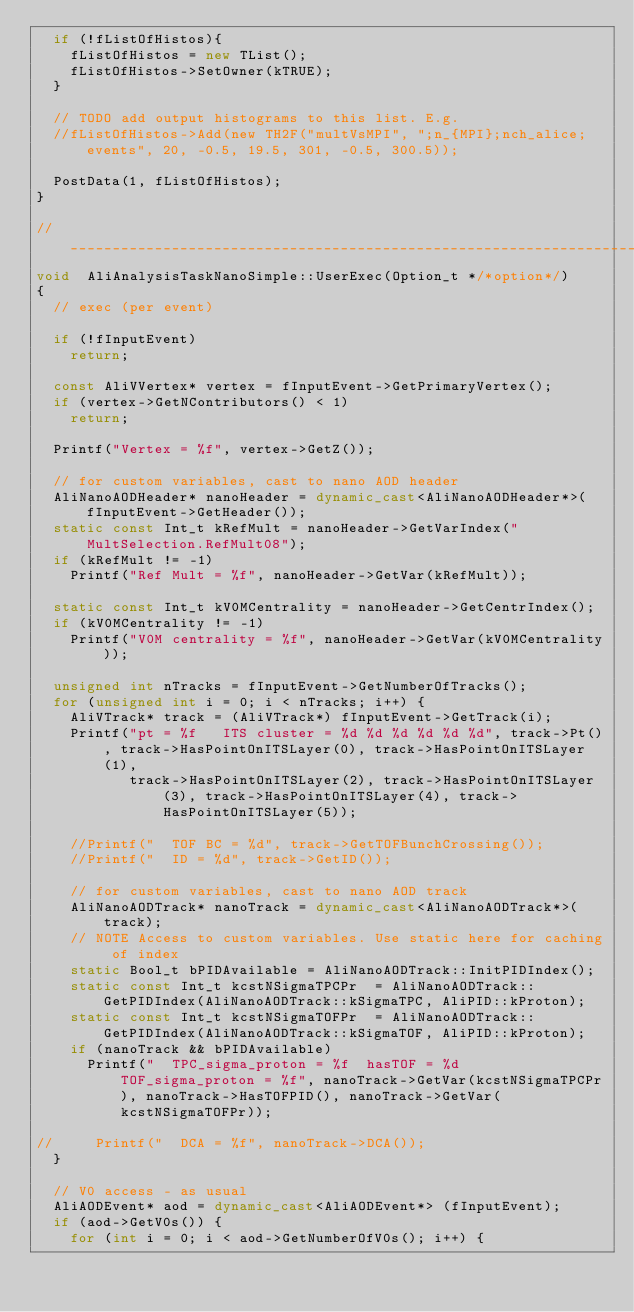<code> <loc_0><loc_0><loc_500><loc_500><_C++_>  if (!fListOfHistos){
    fListOfHistos = new TList();
    fListOfHistos->SetOwner(kTRUE); 
  }

  // TODO add output histograms to this list. E.g.
  //fListOfHistos->Add(new TH2F("multVsMPI", ";n_{MPI};nch_alice;events", 20, -0.5, 19.5, 301, -0.5, 300.5));
  
  PostData(1, fListOfHistos);
}

//____________________________________________________________________
void  AliAnalysisTaskNanoSimple::UserExec(Option_t */*option*/)
{
  // exec (per event)

  if (!fInputEvent)
    return;
  
  const AliVVertex* vertex = fInputEvent->GetPrimaryVertex();
  if (vertex->GetNContributors() < 1)
    return;
  
  Printf("Vertex = %f", vertex->GetZ());
  
  // for custom variables, cast to nano AOD header
  AliNanoAODHeader* nanoHeader = dynamic_cast<AliNanoAODHeader*>(fInputEvent->GetHeader());
  static const Int_t kRefMult = nanoHeader->GetVarIndex("MultSelection.RefMult08");
  if (kRefMult != -1)
    Printf("Ref Mult = %f", nanoHeader->GetVar(kRefMult));

  static const Int_t kV0MCentrality = nanoHeader->GetCentrIndex();
  if (kV0MCentrality != -1)
    Printf("V0M centrality = %f", nanoHeader->GetVar(kV0MCentrality));
  
  unsigned int nTracks = fInputEvent->GetNumberOfTracks();
  for (unsigned int i = 0; i < nTracks; i++) {
    AliVTrack* track = (AliVTrack*) fInputEvent->GetTrack(i);
    Printf("pt = %f   ITS cluster = %d %d %d %d %d %d", track->Pt(), track->HasPointOnITSLayer(0), track->HasPointOnITSLayer(1), 
           track->HasPointOnITSLayer(2), track->HasPointOnITSLayer(3), track->HasPointOnITSLayer(4), track->HasPointOnITSLayer(5));
    
    //Printf("  TOF BC = %d", track->GetTOFBunchCrossing());
    //Printf("  ID = %d", track->GetID());
    
    // for custom variables, cast to nano AOD track
    AliNanoAODTrack* nanoTrack = dynamic_cast<AliNanoAODTrack*>(track);
    // NOTE Access to custom variables. Use static here for caching of index
    static Bool_t bPIDAvailable = AliNanoAODTrack::InitPIDIndex();
    static const Int_t kcstNSigmaTPCPr  = AliNanoAODTrack::GetPIDIndex(AliNanoAODTrack::kSigmaTPC, AliPID::kProton);
    static const Int_t kcstNSigmaTOFPr  = AliNanoAODTrack::GetPIDIndex(AliNanoAODTrack::kSigmaTOF, AliPID::kProton);
    if (nanoTrack && bPIDAvailable)
      Printf("  TPC_sigma_proton = %f  hasTOF = %d  TOF_sigma_proton = %f", nanoTrack->GetVar(kcstNSigmaTPCPr), nanoTrack->HasTOFPID(), nanoTrack->GetVar(kcstNSigmaTOFPr));

//     Printf("  DCA = %f", nanoTrack->DCA());
  }
  
  // V0 access - as usual
  AliAODEvent* aod = dynamic_cast<AliAODEvent*> (fInputEvent);
  if (aod->GetV0s()) {
    for (int i = 0; i < aod->GetNumberOfV0s(); i++) {</code> 